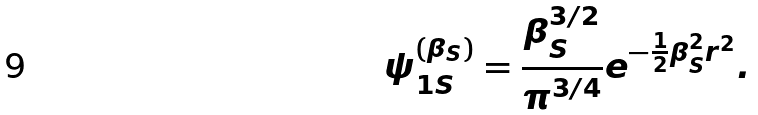Convert formula to latex. <formula><loc_0><loc_0><loc_500><loc_500>\psi _ { 1 S } ^ { ( \beta _ { S } ) } = { { \frac { \beta _ { S } ^ { 3 / 2 } } { \pi ^ { 3 / 4 } } } e ^ { - { \frac { 1 } { 2 } } \beta _ { S } ^ { 2 } r ^ { 2 } } } .</formula> 